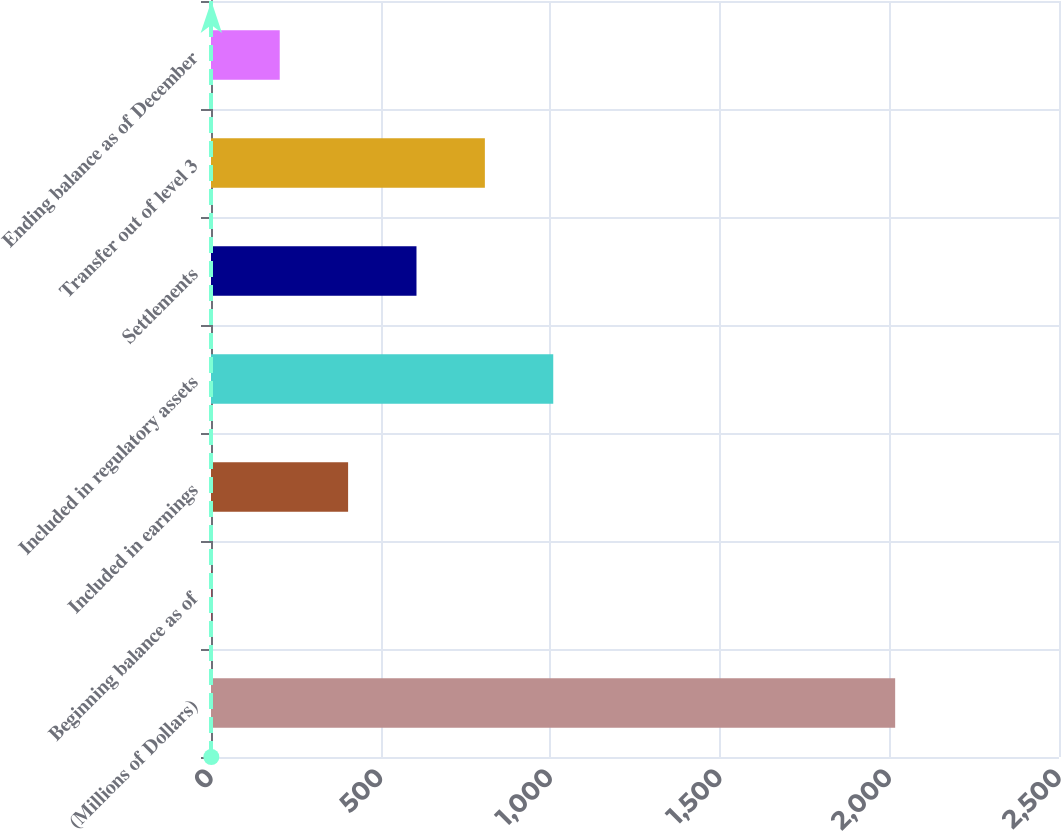Convert chart. <chart><loc_0><loc_0><loc_500><loc_500><bar_chart><fcel>(Millions of Dollars)<fcel>Beginning balance as of<fcel>Included in earnings<fcel>Included in regulatory assets<fcel>Settlements<fcel>Transfer out of level 3<fcel>Ending balance as of December<nl><fcel>2017<fcel>1<fcel>404.2<fcel>1009<fcel>605.8<fcel>807.4<fcel>202.6<nl></chart> 